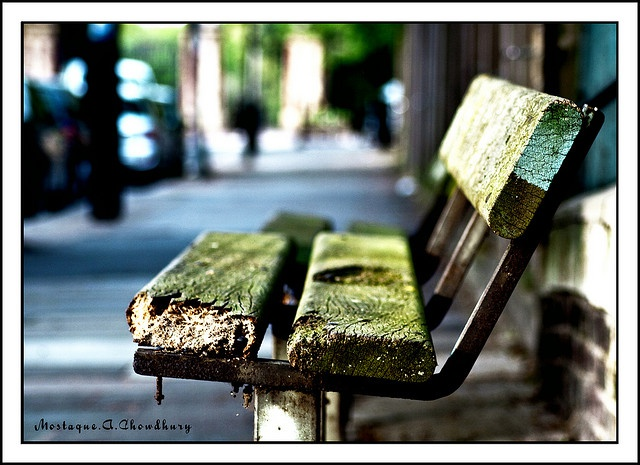Describe the objects in this image and their specific colors. I can see bench in black, ivory, olive, and khaki tones, car in black, white, lightblue, and teal tones, and people in black, blue, and gray tones in this image. 